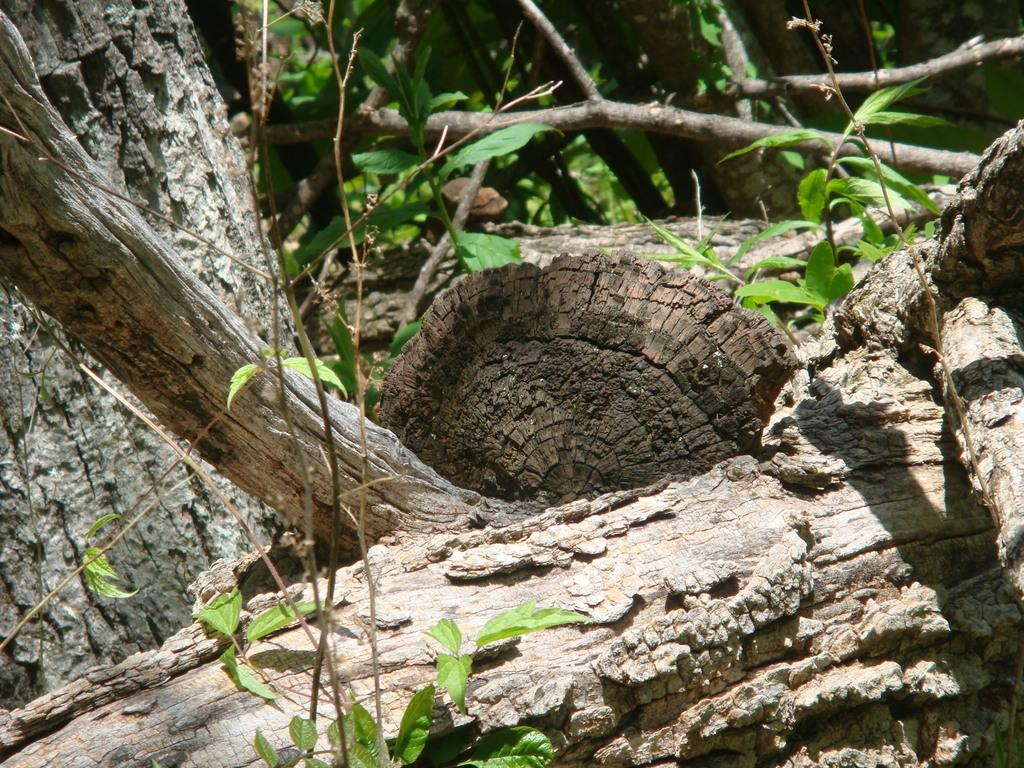What can be seen in the foreground of the image? There are trees and plants in the foreground of the image. What can be seen in the background of the image? There are trees and plants in the background of the image. Can you describe the vegetation in the image? The image features both trees and plants in the foreground and background. How many veins are visible on the trees in the image? There are no veins visible on the trees in the image, as veins are not present in trees. 